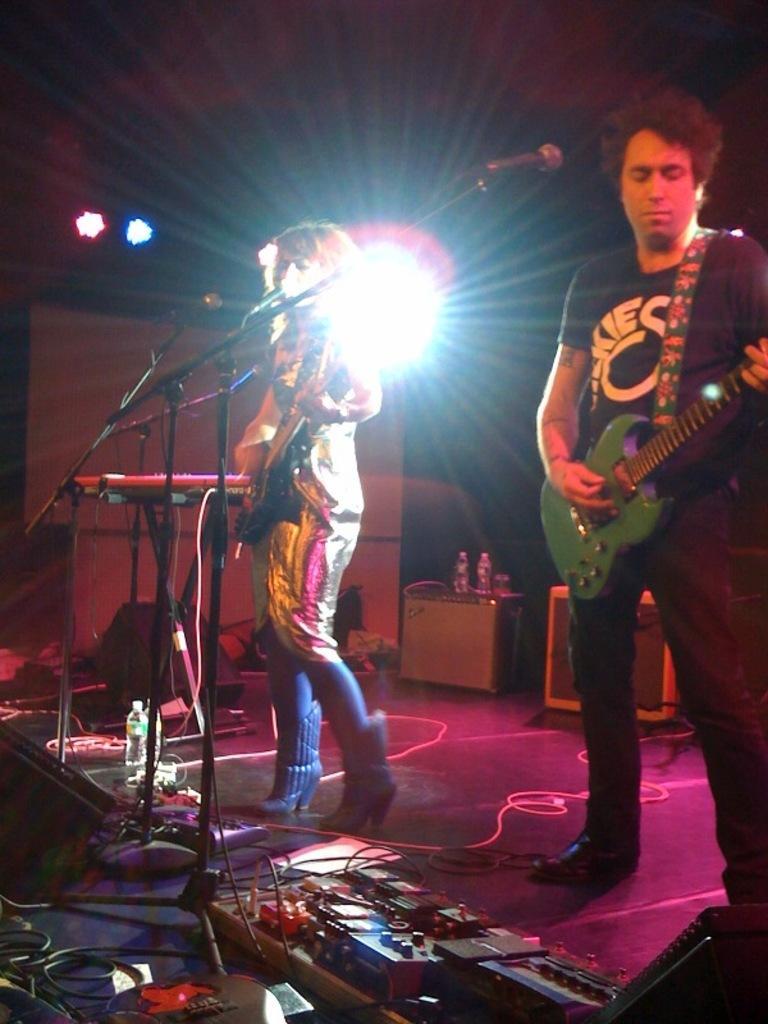Could you give a brief overview of what you see in this image? As we can see in the image there are two people standing on stage and holding guitar in their hands. In front of them there are mics. 